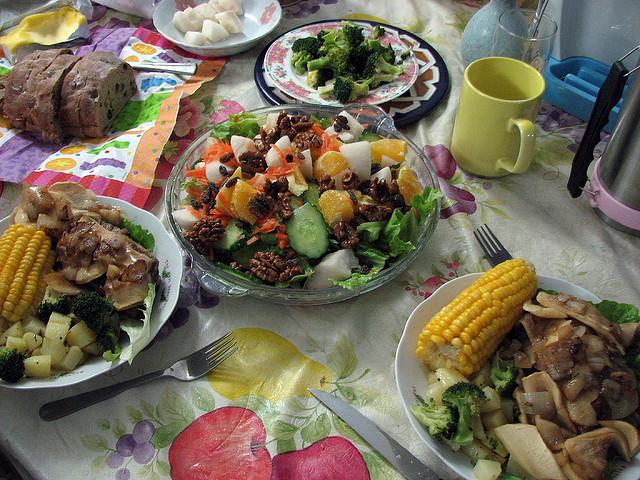Is this someone's home?
Give a very brief answer. Yes. What are in the bowls on the bottom left?
Write a very short answer. Food. Can one person eat all this food?
Keep it brief. No. What color is the coffee mug?
Concise answer only. Yellow. Is there blueberries in the picture?
Quick response, please. No. Are there a variety of foods on the table?
Short answer required. Yes. How many ears of corn are there?
Short answer required. 2. 